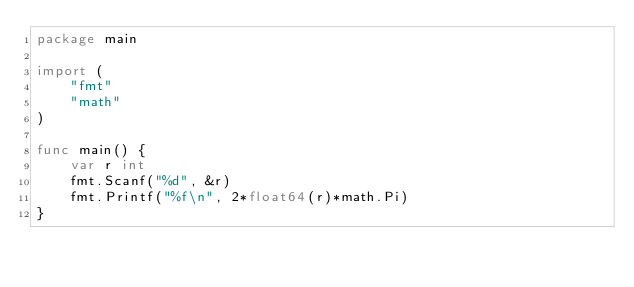<code> <loc_0><loc_0><loc_500><loc_500><_Go_>package main

import (
	"fmt"
	"math"
)

func main() {
	var r int
	fmt.Scanf("%d", &r)
	fmt.Printf("%f\n", 2*float64(r)*math.Pi)
}
</code> 